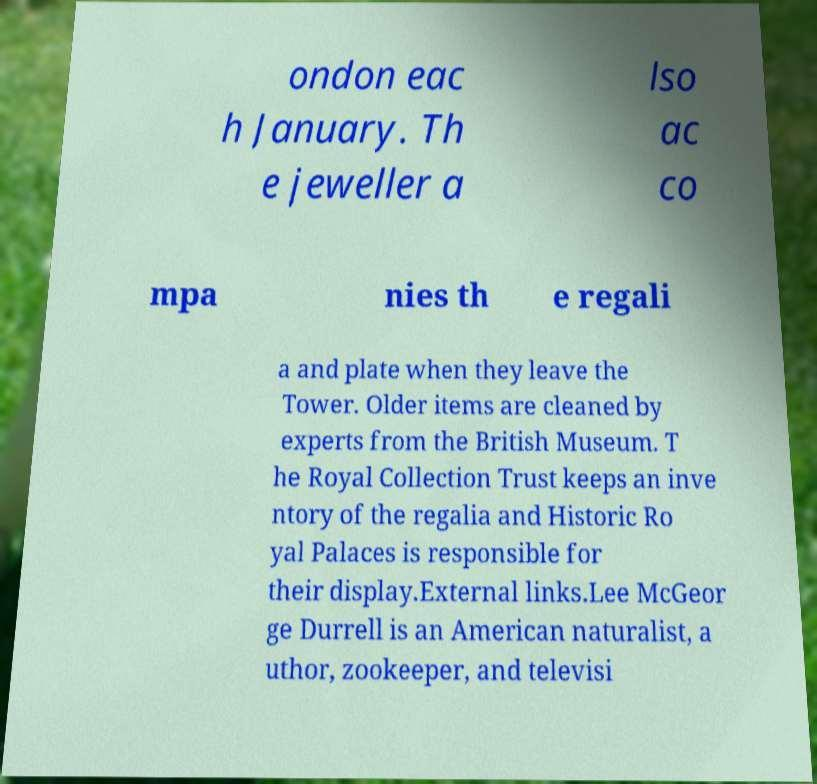What messages or text are displayed in this image? I need them in a readable, typed format. ondon eac h January. Th e jeweller a lso ac co mpa nies th e regali a and plate when they leave the Tower. Older items are cleaned by experts from the British Museum. T he Royal Collection Trust keeps an inve ntory of the regalia and Historic Ro yal Palaces is responsible for their display.External links.Lee McGeor ge Durrell is an American naturalist, a uthor, zookeeper, and televisi 